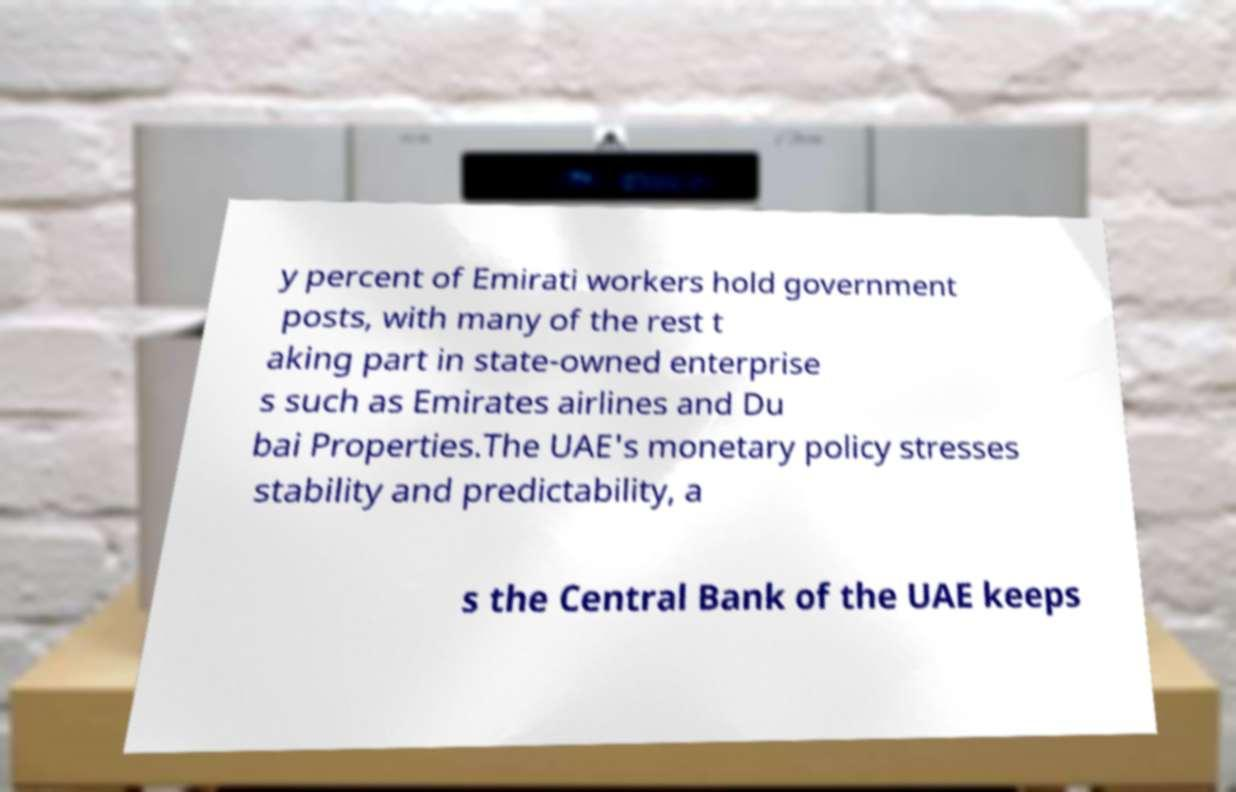There's text embedded in this image that I need extracted. Can you transcribe it verbatim? y percent of Emirati workers hold government posts, with many of the rest t aking part in state-owned enterprise s such as Emirates airlines and Du bai Properties.The UAE's monetary policy stresses stability and predictability, a s the Central Bank of the UAE keeps 